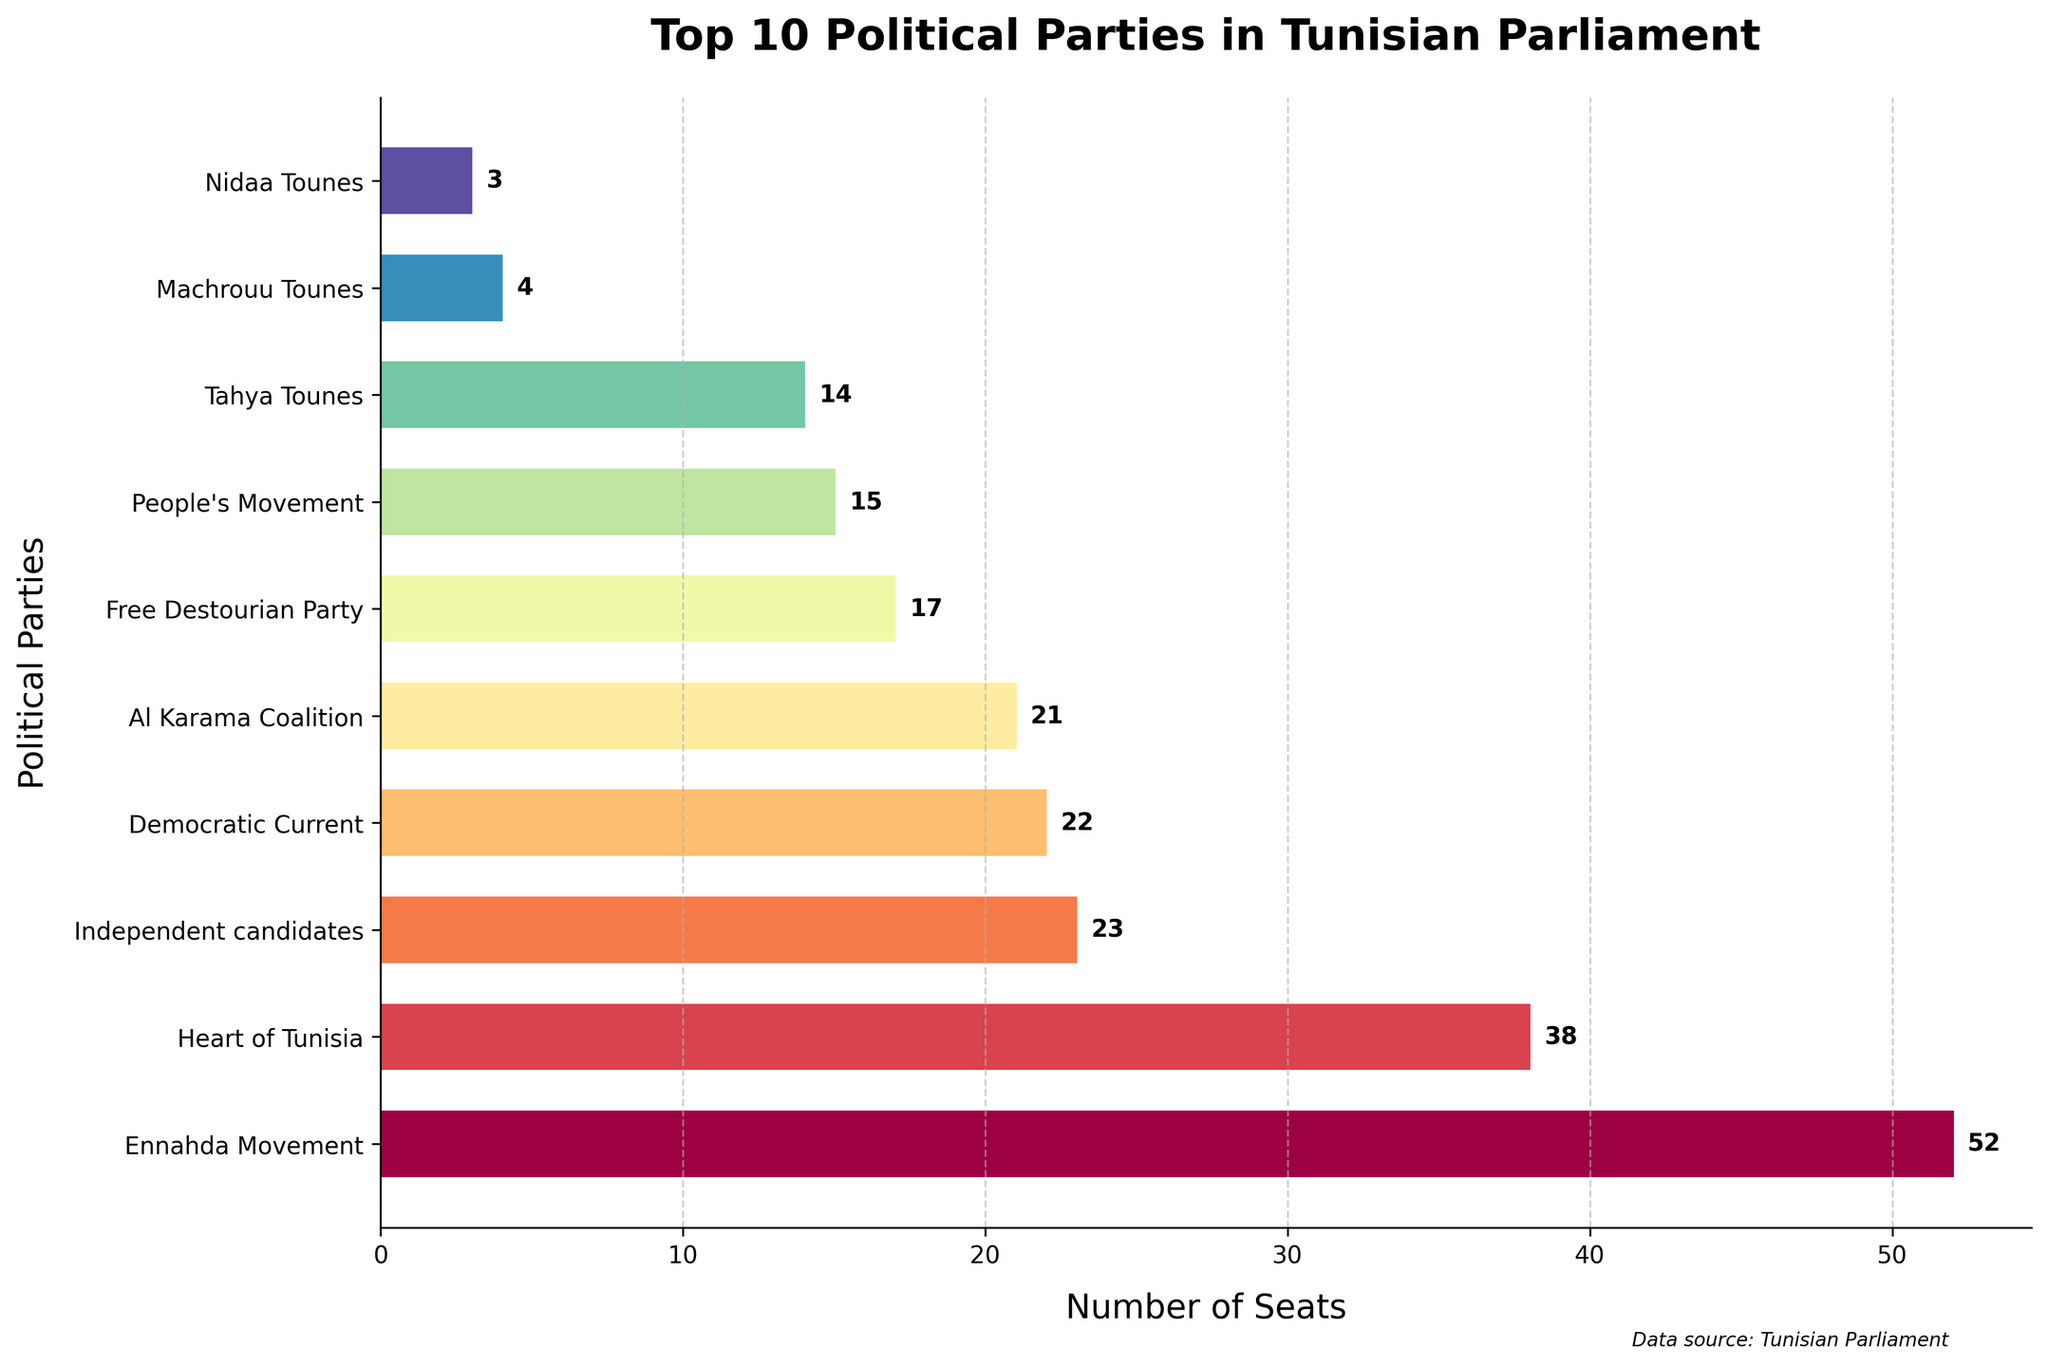Which political party holds the most seats in the Tunisian Parliament? Looking at the bar chart, the bar representing the Ennahda Movement is the longest with 52 seats, indicating it holds the most seats in the Parliament.
Answer: Ennahda Movement What is the combined number of seats held by the Democratic Current and Al Karama Coalition? The Democratic Current holds 22 seats and the Al Karama Coalition holds 21 seats. Adding these together: 22 + 21 = 43
Answer: 43 How many more seats does the Ennahda Movement have compared to the Free Destourian Party? The Ennahda Movement has 52 seats, while the Free Destourian Party has 17 seats. The difference is calculated as 52 - 17 = 35
Answer: 35 Which party holds the fewest seats among the top 10 parties? Among the top 10 parties displayed, Machrouu Tounes holds the fewest seats with 4 seats.
Answer: Machrouu Tounes Is the number of seats held by the Heart of Tunisia greater than those by Tahya Tounes and People's Movement combined? Heart of Tunisia has 38 seats. Tahya Tounes has 14 seats and People's Movement has 15 seats. Combined, Tahya Tounes and People's Movement hold 14 + 15 = 29 seats. Since 38 > 29, Heart of Tunisia holds more seats.
Answer: Yes What is the difference in the number of seats between the party with the third most seats and the party with the second most seats? The party with the third most seats, Democratic Current, has 22 seats. The party with the second most seats, Heart of Tunisia, has 38 seats. The difference is 38 - 22 = 16
Answer: 16 Which political party is represented by the second longest bar in the chart? The second longest bar corresponds to Heart of Tunisia, which holds 38 seats.
Answer: Heart of Tunisia How many seats are held by all parties with fewer than 10 seats combined among the top 10 parties? Machrouu Tounes (4 seats), Nidaa Tounes (3 seats), Afek Tounes (2 seats), Workers' Party (2 seats), Popular Front (1 seat), Errahma (1 seat), Tunisian Alternative (1 seat), and Alliance for Tunisia (1 seat) have less than 10 seats each. Their combined seats are 4 + 3 + 2 + 2 + 1 + 1 + 1 + 1 = 15
Answer: 15 Which parties in the top 10 have more than 20 seats? Ennahda Movement (52 seats), Heart of Tunisia (38 seats), Democratic Current (22 seats), and Al Karama Coalition (21 seats) each have more than 20 seats.
Answer: Ennahda Movement, Heart of Tunisia, Democratic Current, Al Karama Coalition 